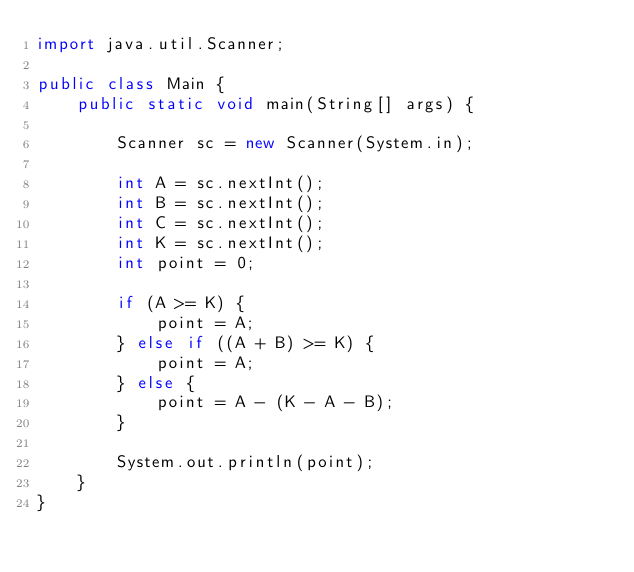<code> <loc_0><loc_0><loc_500><loc_500><_Java_>import java.util.Scanner;

public class Main {
    public static void main(String[] args) {

        Scanner sc = new Scanner(System.in);

        int A = sc.nextInt();
        int B = sc.nextInt();
        int C = sc.nextInt();
        int K = sc.nextInt();
        int point = 0;

        if (A >= K) {
            point = A;
        } else if ((A + B) >= K) {
            point = A;
        } else {
            point = A - (K - A - B);
        }

        System.out.println(point);
    }
}</code> 